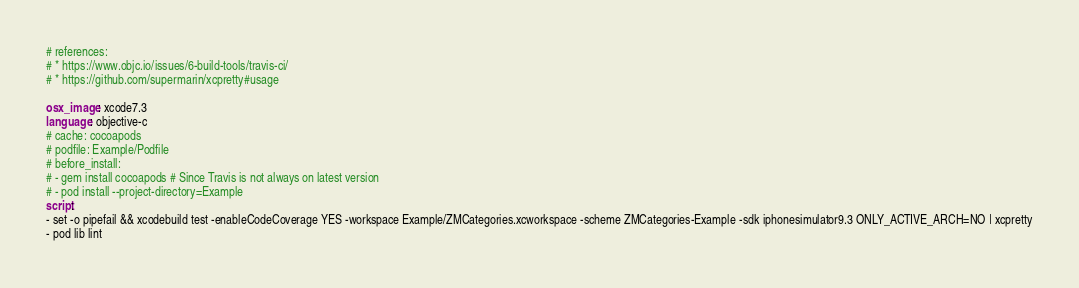Convert code to text. <code><loc_0><loc_0><loc_500><loc_500><_YAML_># references:
# * https://www.objc.io/issues/6-build-tools/travis-ci/
# * https://github.com/supermarin/xcpretty#usage

osx_image: xcode7.3
language: objective-c
# cache: cocoapods
# podfile: Example/Podfile
# before_install:
# - gem install cocoapods # Since Travis is not always on latest version
# - pod install --project-directory=Example
script:
- set -o pipefail && xcodebuild test -enableCodeCoverage YES -workspace Example/ZMCategories.xcworkspace -scheme ZMCategories-Example -sdk iphonesimulator9.3 ONLY_ACTIVE_ARCH=NO | xcpretty
- pod lib lint
</code> 